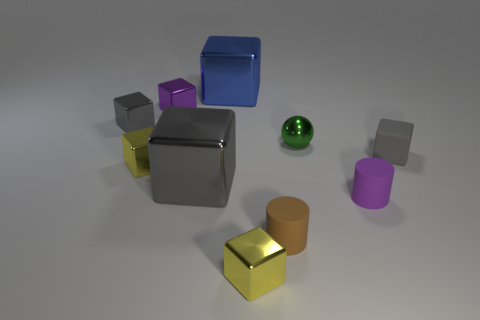There is a tiny gray thing that is to the right of the large metal block that is in front of the matte thing behind the purple rubber object; what is its shape?
Ensure brevity in your answer.  Cube. Is the number of small green objects that are to the right of the purple cylinder the same as the number of small green objects?
Provide a short and direct response. No. Do the purple matte cylinder and the green ball have the same size?
Your response must be concise. Yes. What number of metallic things are green spheres or yellow objects?
Make the answer very short. 3. There is a purple object that is the same size as the purple metal block; what material is it?
Your response must be concise. Rubber. How many other objects are there of the same material as the brown cylinder?
Your response must be concise. 2. Is the number of gray matte things that are left of the blue metallic block less than the number of green spheres?
Offer a terse response. Yes. Do the gray matte thing and the purple shiny object have the same shape?
Offer a terse response. Yes. What is the size of the purple object that is left of the small purple object that is in front of the small gray block on the right side of the tiny purple metal cube?
Provide a short and direct response. Small. There is a purple object that is the same shape as the large blue thing; what is it made of?
Give a very brief answer. Metal. 